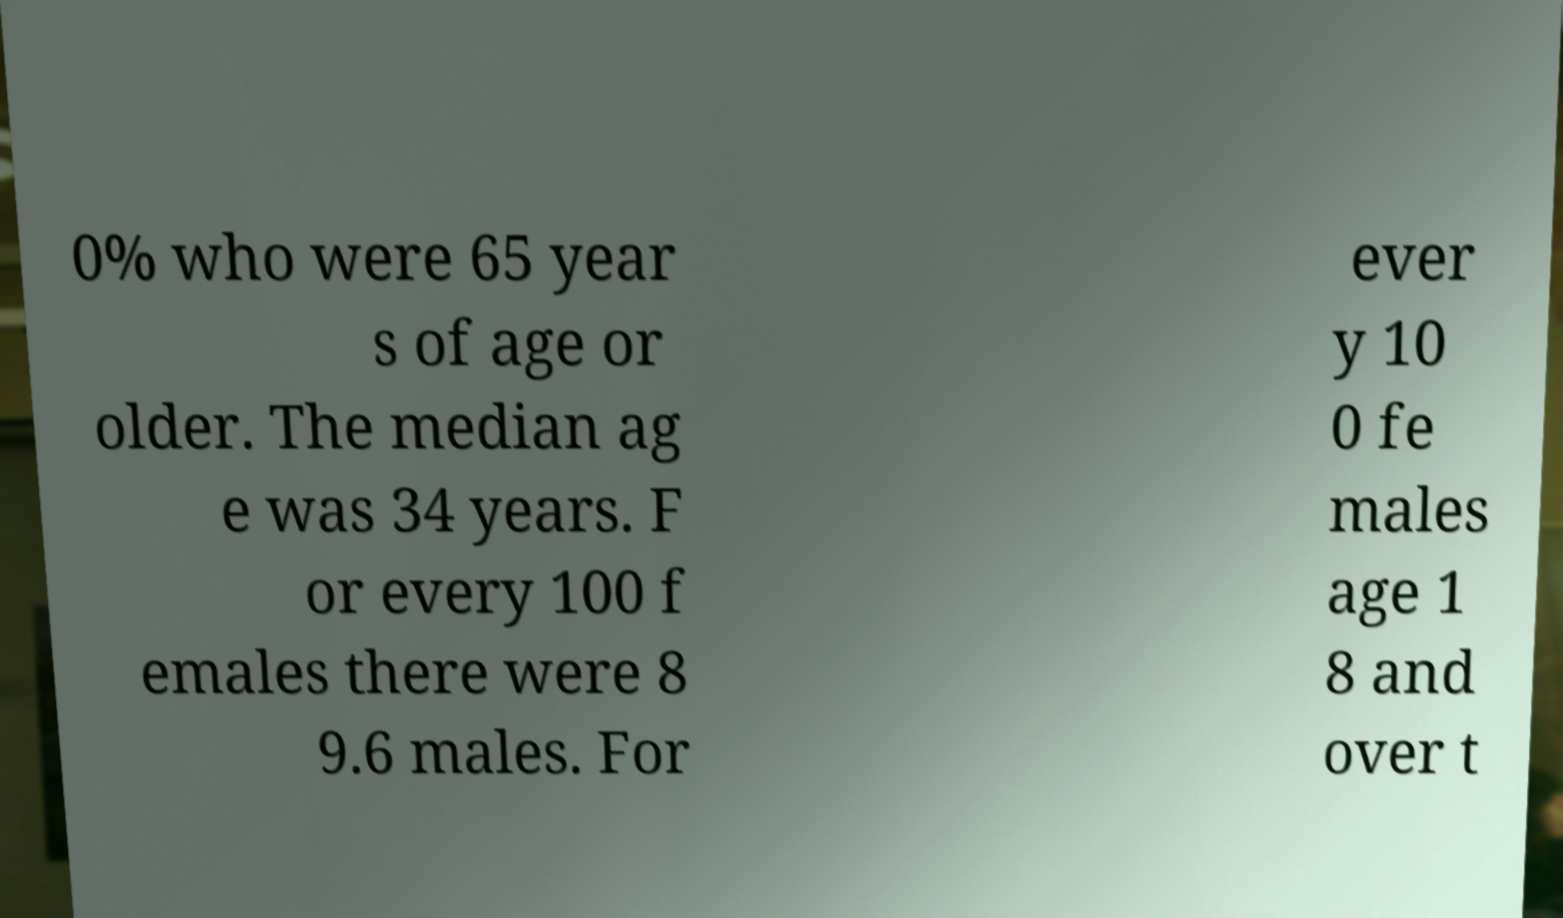Please identify and transcribe the text found in this image. 0% who were 65 year s of age or older. The median ag e was 34 years. F or every 100 f emales there were 8 9.6 males. For ever y 10 0 fe males age 1 8 and over t 